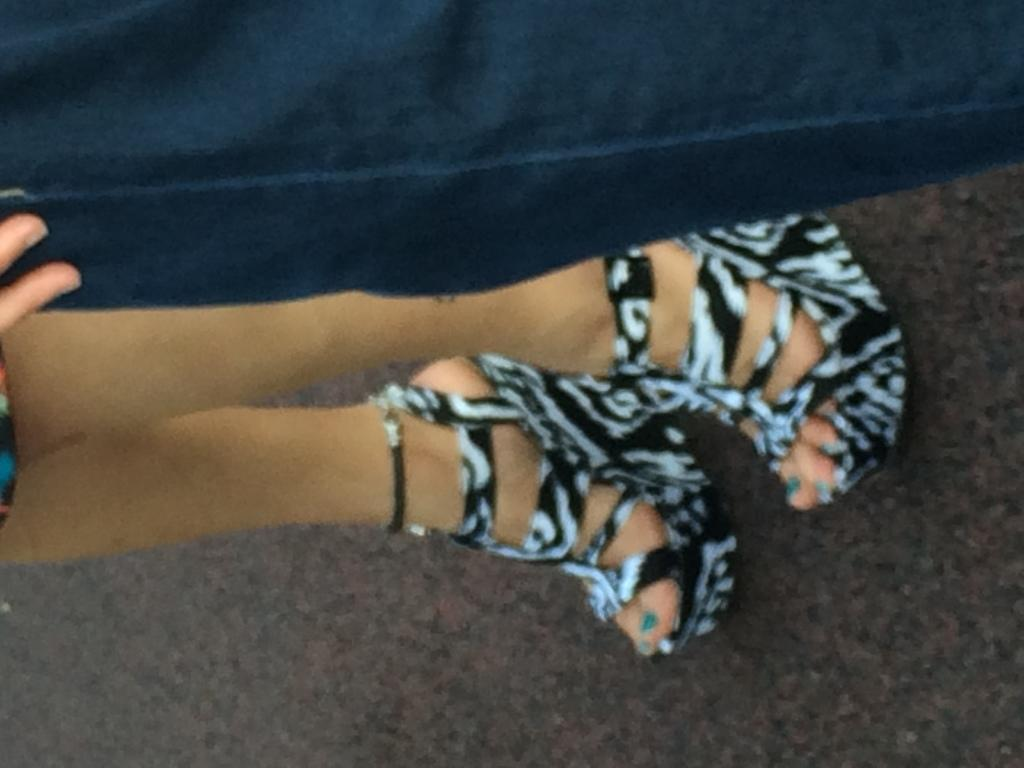What part of a person can be seen in the image? There are legs of a girl visible in the image. What type of footwear is the girl wearing? The girl is wearing heels. What else is present in the image besides the girl's legs? There is a pant beside the girl in the image. How many fingers can be seen touching the dirt in the image? There is no dirt or fingers visible in the image. 